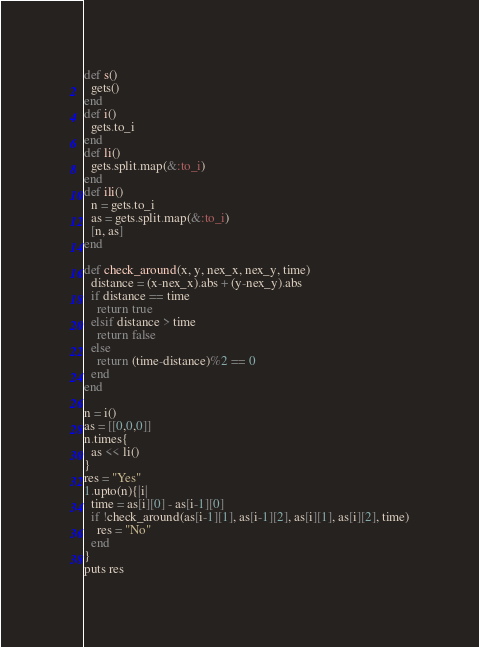Convert code to text. <code><loc_0><loc_0><loc_500><loc_500><_Ruby_>def s()
  gets()
end
def i()
  gets.to_i
end
def li()
  gets.split.map(&:to_i)
end
def ili()
  n = gets.to_i
  as = gets.split.map(&:to_i)
  [n, as]
end

def check_around(x, y, nex_x, nex_y, time)
  distance = (x-nex_x).abs + (y-nex_y).abs
  if distance == time
    return true
  elsif distance > time
    return false
  else
    return (time-distance)%2 == 0
  end
end

n = i()
as = [[0,0,0]]
n.times{
  as << li()
}
res = "Yes"
1.upto(n){|i|
  time = as[i][0] - as[i-1][0]
  if !check_around(as[i-1][1], as[i-1][2], as[i][1], as[i][2], time)
    res = "No"
  end
}
puts res</code> 